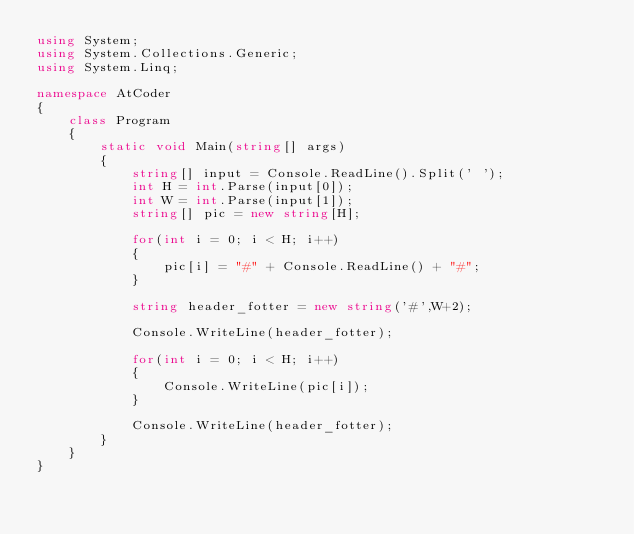Convert code to text. <code><loc_0><loc_0><loc_500><loc_500><_C#_>using System;
using System.Collections.Generic;
using System.Linq;

namespace AtCoder
{
    class Program
    {
        static void Main(string[] args)
        {
            string[] input = Console.ReadLine().Split(' ');
            int H = int.Parse(input[0]);
            int W = int.Parse(input[1]);
            string[] pic = new string[H];

            for(int i = 0; i < H; i++)
            {
                pic[i] = "#" + Console.ReadLine() + "#";
            }

            string header_fotter = new string('#',W+2);

            Console.WriteLine(header_fotter);

            for(int i = 0; i < H; i++)
            {
                Console.WriteLine(pic[i]);
            }

            Console.WriteLine(header_fotter);
        }
    }
}
</code> 